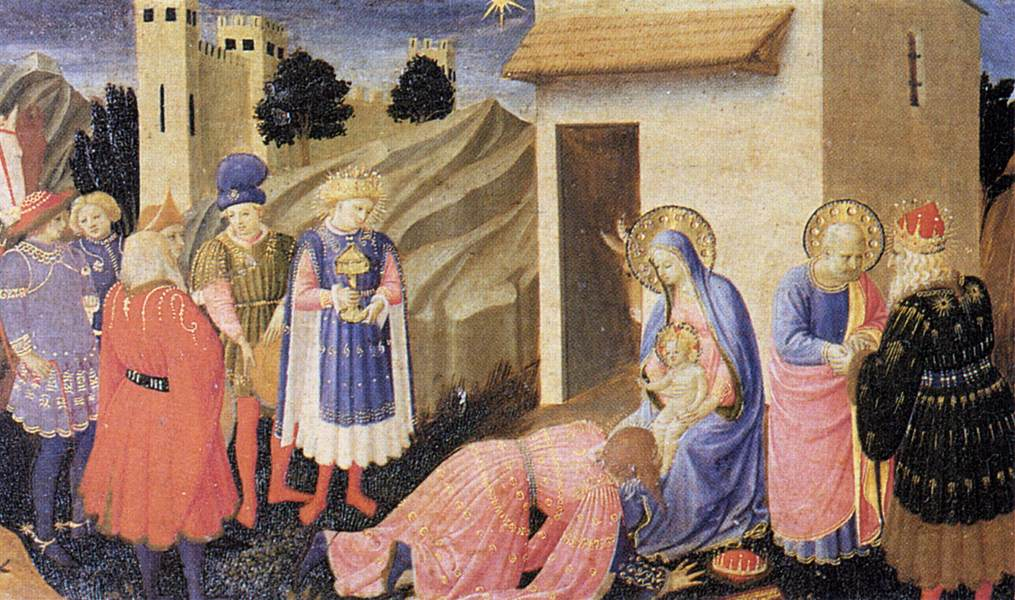Imagine this scene takes place in a modern urban setting. How would the elements of the painting change? In a modern urban setting, the elements of the painting would undergo significant transformations to reflect contemporary times. The stable might be depicted as a small, humble shelter amidst towering skyscrapers, symbolizing the stark contrast between the humble birth of Jesus and the sprawling cityscape. The Virgin Mary might be dressed in modest, modern-day clothing, and Jesus could be swaddled in a simple blanket. The Magi could arrive in sleek cars or dressed in business attire, carrying modern gifts like technology or symbolic items of today's culture. The castle and church could be replaced by significant urban landmarks, perhaps a grand historical building representing earthly power and a modern cathedral symbolizing spiritual authority. The Star of Bethlehem might be represented as a bright, singular light in the night sky, perhaps as a powerful spotlight or a prominent star sign or neon light that stands out amidst the city lights, maintaining its role as a divine guide in an urban context. What if the scene was happening under water, what would it depict? Imagining this scene underwater would create an otherworldly and symbolic representation. The stable would be a coral cave adorned with sea anemones and delicate underwater plants. The Virgin Mary, portrayed as a benevolent sea deity, would be clothed in flowing, translucent robes that merge with the water, and the infant Jesus as a radiant figure surrounded by a halo of light and bubbles. The Magi, as wise mermen, would offer gifts like pearls, rare underwater artifacts, or luminescent objects found in the depths of the ocean. Surrounding them, a mystical underwater kingdom would replace the castle and church, complete with vibrant marine life, adding a unique dynamic to the scene. The Star of Bethlehem might be symbolized by a glowing jellyfish or a collection of bioluminescent creatures, guiding the Wise Men through the dark waters to the holy scene. This underwater setting would add an enchanting and surreal twist to the traditional narrative, highlighting the universality and timelessness of the story. 